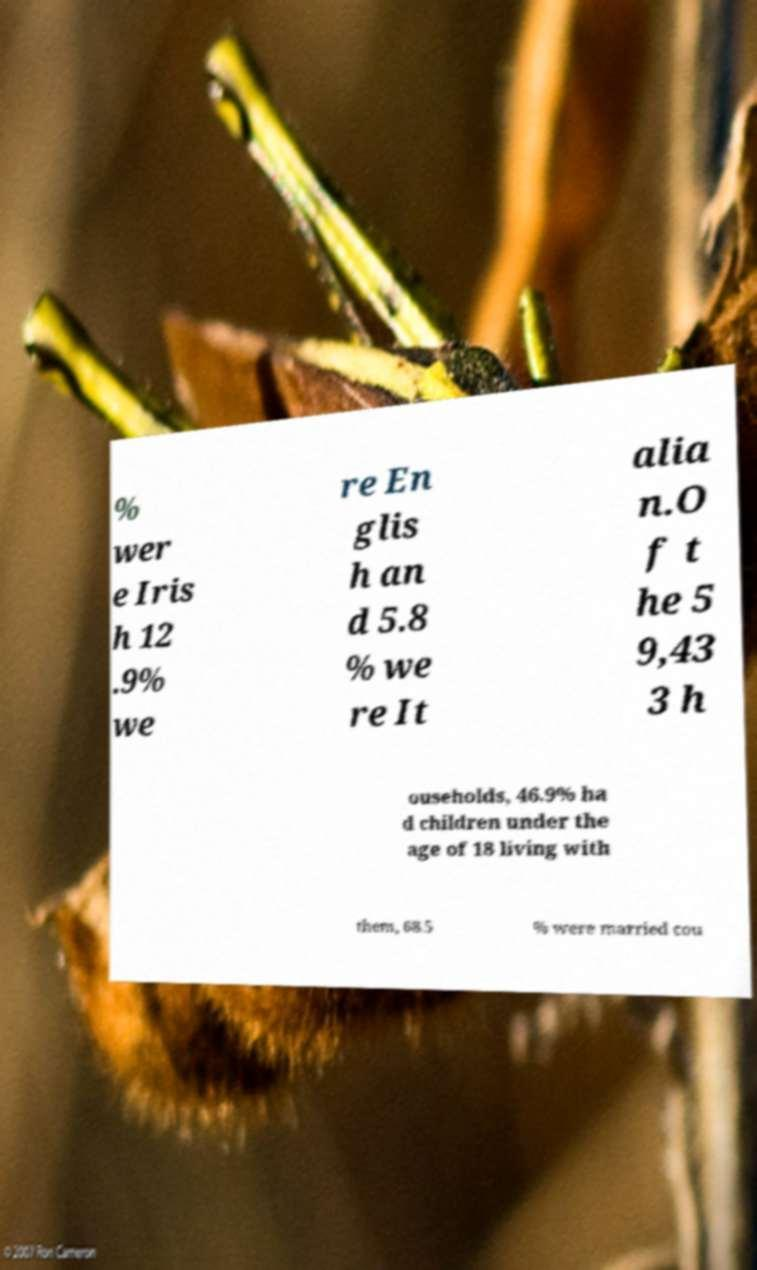Could you extract and type out the text from this image? % wer e Iris h 12 .9% we re En glis h an d 5.8 % we re It alia n.O f t he 5 9,43 3 h ouseholds, 46.9% ha d children under the age of 18 living with them, 68.5 % were married cou 